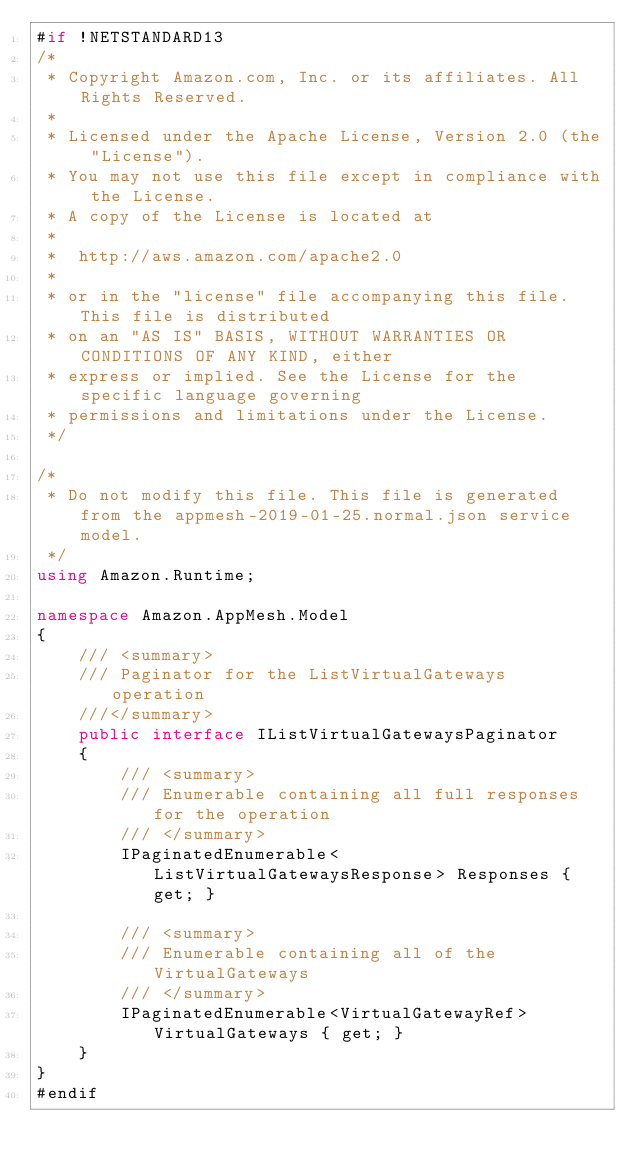Convert code to text. <code><loc_0><loc_0><loc_500><loc_500><_C#_>#if !NETSTANDARD13
/*
 * Copyright Amazon.com, Inc. or its affiliates. All Rights Reserved.
 * 
 * Licensed under the Apache License, Version 2.0 (the "License").
 * You may not use this file except in compliance with the License.
 * A copy of the License is located at
 * 
 *  http://aws.amazon.com/apache2.0
 * 
 * or in the "license" file accompanying this file. This file is distributed
 * on an "AS IS" BASIS, WITHOUT WARRANTIES OR CONDITIONS OF ANY KIND, either
 * express or implied. See the License for the specific language governing
 * permissions and limitations under the License.
 */

/*
 * Do not modify this file. This file is generated from the appmesh-2019-01-25.normal.json service model.
 */
using Amazon.Runtime;

namespace Amazon.AppMesh.Model
{
    /// <summary>
    /// Paginator for the ListVirtualGateways operation
    ///</summary>
    public interface IListVirtualGatewaysPaginator
    {
        /// <summary>
        /// Enumerable containing all full responses for the operation
        /// </summary>
        IPaginatedEnumerable<ListVirtualGatewaysResponse> Responses { get; }

        /// <summary>
        /// Enumerable containing all of the VirtualGateways
        /// </summary>
        IPaginatedEnumerable<VirtualGatewayRef> VirtualGateways { get; }
    }
}
#endif</code> 